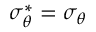<formula> <loc_0><loc_0><loc_500><loc_500>\sigma _ { \theta } ^ { * } = \sigma _ { \theta }</formula> 